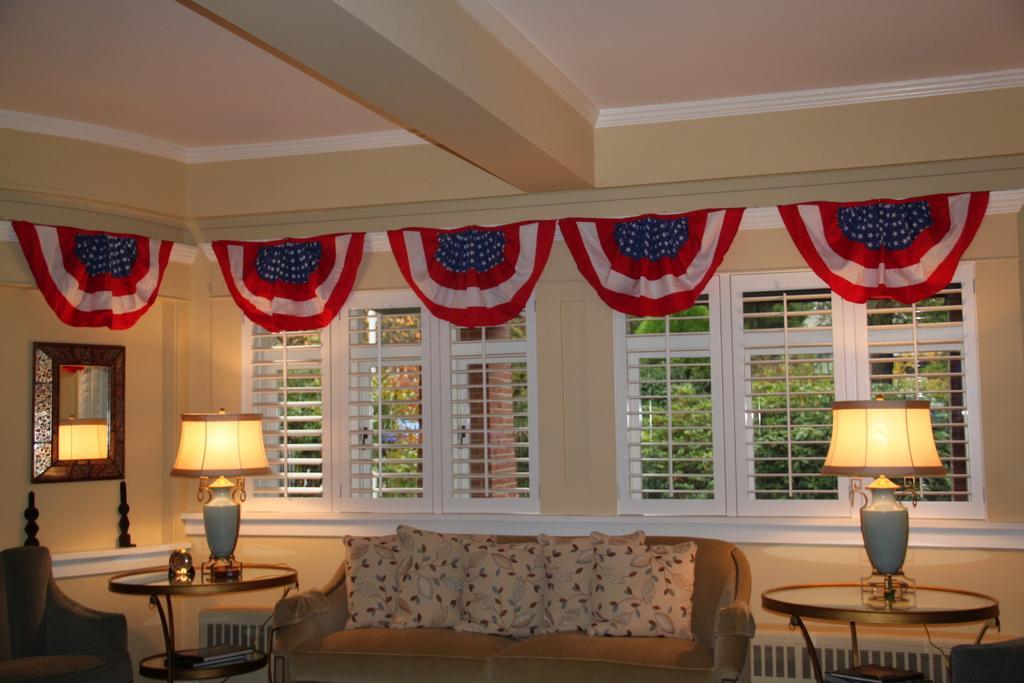Please provide a concise description of this image. This picture shows an inner view of a house we see a sofa and pillows on it and we see a chair and a couple of lamps on the tables and we see two windows and from the windows we see trees and few cotton clothes on the top and we see a mirror to the left 